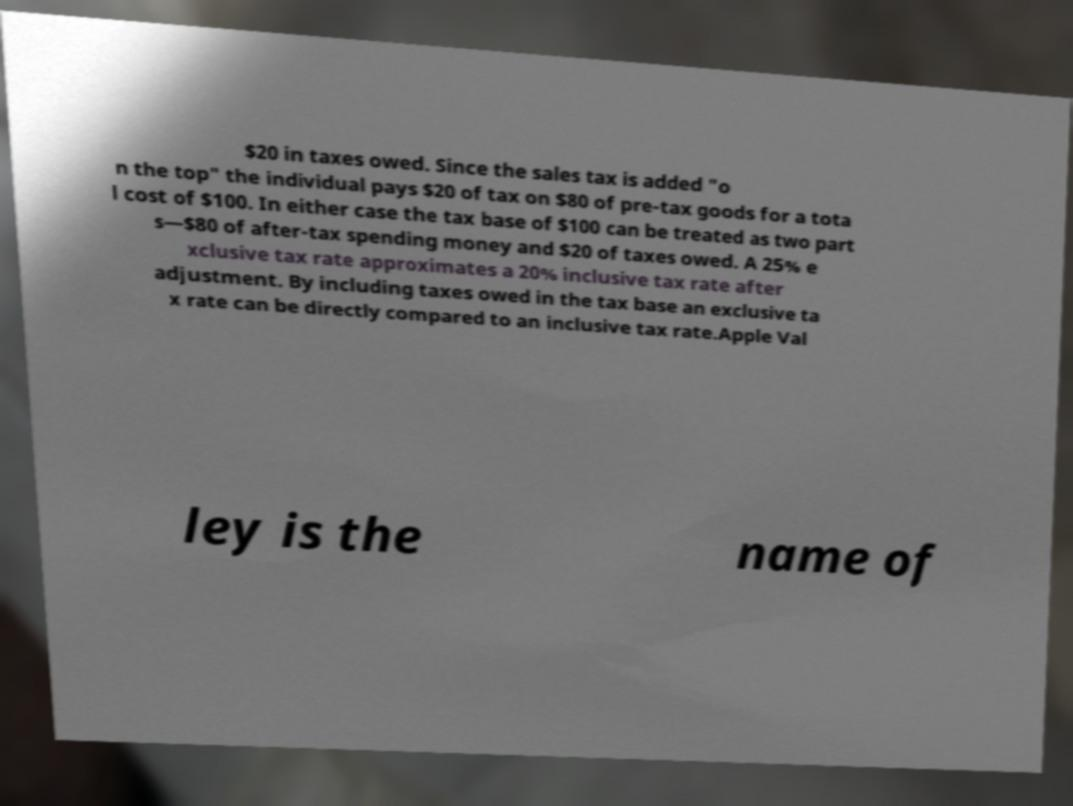For documentation purposes, I need the text within this image transcribed. Could you provide that? $20 in taxes owed. Since the sales tax is added "o n the top" the individual pays $20 of tax on $80 of pre-tax goods for a tota l cost of $100. In either case the tax base of $100 can be treated as two part s—$80 of after-tax spending money and $20 of taxes owed. A 25% e xclusive tax rate approximates a 20% inclusive tax rate after adjustment. By including taxes owed in the tax base an exclusive ta x rate can be directly compared to an inclusive tax rate.Apple Val ley is the name of 